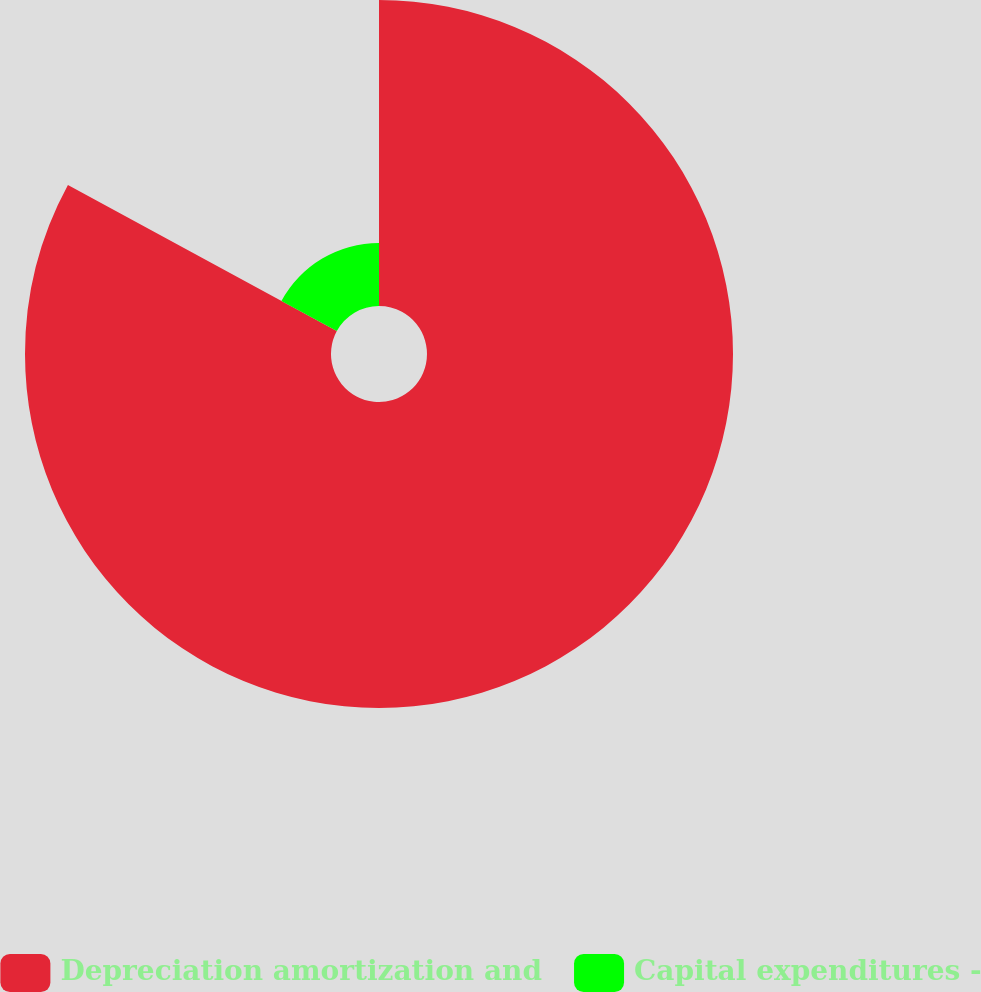Convert chart. <chart><loc_0><loc_0><loc_500><loc_500><pie_chart><fcel>Depreciation amortization and<fcel>Capital expenditures -<nl><fcel>82.92%<fcel>17.08%<nl></chart> 